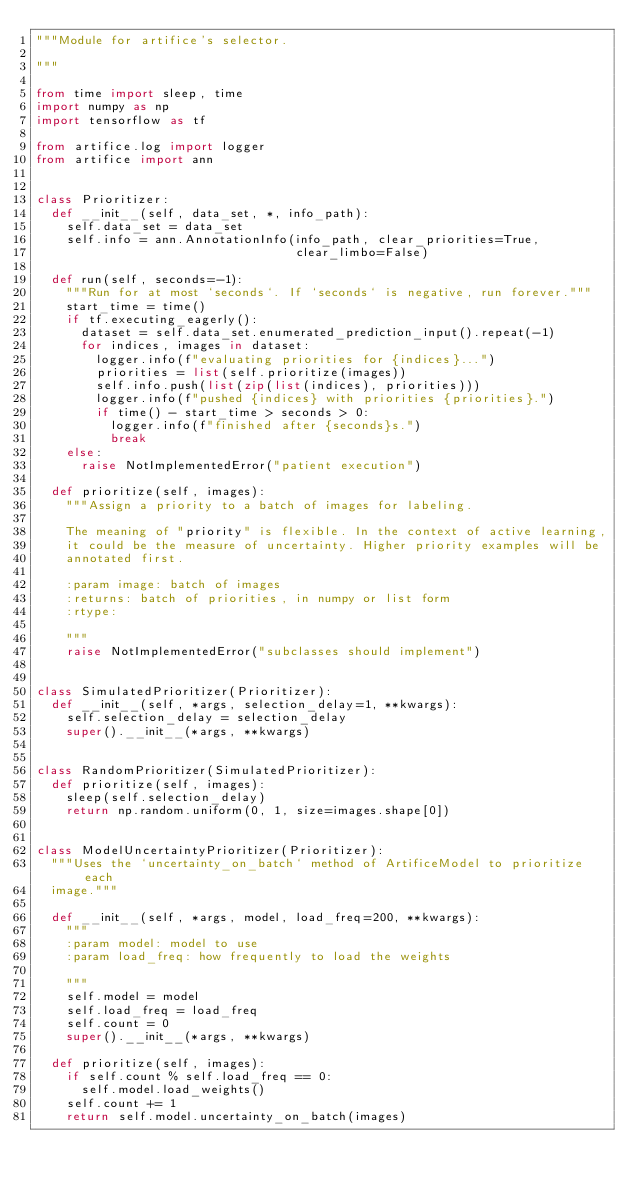<code> <loc_0><loc_0><loc_500><loc_500><_Python_>"""Module for artifice's selector.

"""

from time import sleep, time
import numpy as np
import tensorflow as tf

from artifice.log import logger
from artifice import ann


class Prioritizer:
  def __init__(self, data_set, *, info_path):
    self.data_set = data_set
    self.info = ann.AnnotationInfo(info_path, clear_priorities=True,
                                   clear_limbo=False)

  def run(self, seconds=-1):
    """Run for at most `seconds`. If `seconds` is negative, run forever."""
    start_time = time()
    if tf.executing_eagerly():
      dataset = self.data_set.enumerated_prediction_input().repeat(-1)
      for indices, images in dataset:
        logger.info(f"evaluating priorities for {indices}...")
        priorities = list(self.prioritize(images))
        self.info.push(list(zip(list(indices), priorities)))
        logger.info(f"pushed {indices} with priorities {priorities}.")
        if time() - start_time > seconds > 0:
          logger.info(f"finished after {seconds}s.")
          break
    else:
      raise NotImplementedError("patient execution")

  def prioritize(self, images):
    """Assign a priority to a batch of images for labeling.

    The meaning of "priority" is flexible. In the context of active learning,
    it could be the measure of uncertainty. Higher priority examples will be
    annotated first.

    :param image: batch of images
    :returns: batch of priorities, in numpy or list form
    :rtype:

    """
    raise NotImplementedError("subclasses should implement")


class SimulatedPrioritizer(Prioritizer):
  def __init__(self, *args, selection_delay=1, **kwargs):
    self.selection_delay = selection_delay
    super().__init__(*args, **kwargs)


class RandomPrioritizer(SimulatedPrioritizer):
  def prioritize(self, images):
    sleep(self.selection_delay)
    return np.random.uniform(0, 1, size=images.shape[0])


class ModelUncertaintyPrioritizer(Prioritizer):
  """Uses the `uncertainty_on_batch` method of ArtificeModel to prioritize each
  image."""

  def __init__(self, *args, model, load_freq=200, **kwargs):
    """
    :param model: model to use
    :param load_freq: how frequently to load the weights

    """
    self.model = model
    self.load_freq = load_freq
    self.count = 0
    super().__init__(*args, **kwargs)

  def prioritize(self, images):
    if self.count % self.load_freq == 0:
      self.model.load_weights()
    self.count += 1
    return self.model.uncertainty_on_batch(images)
</code> 